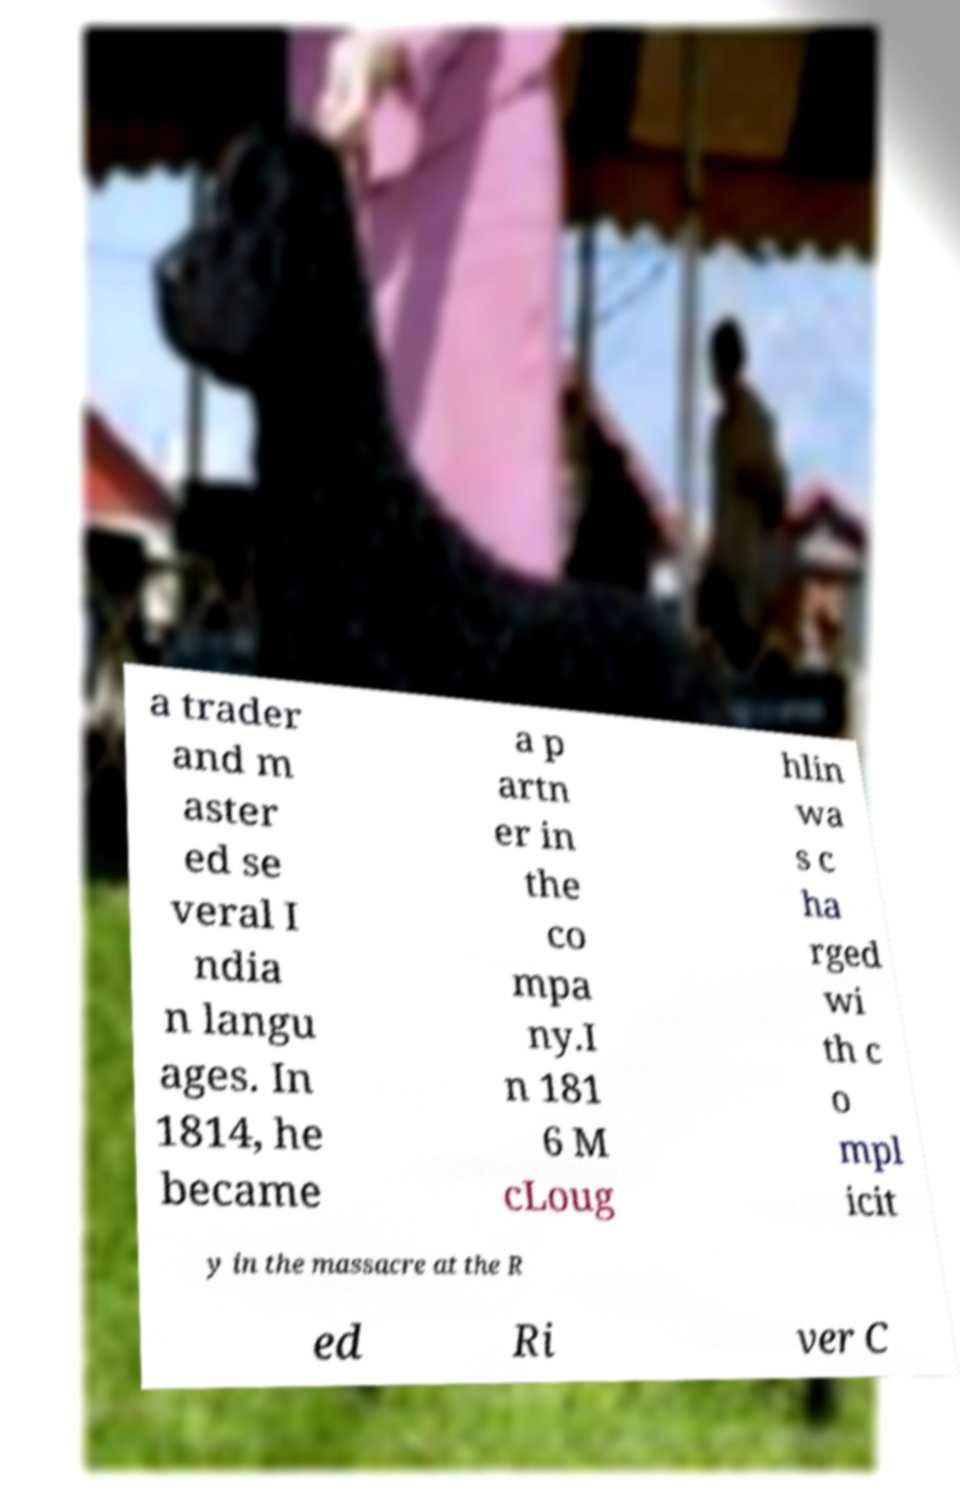Please read and relay the text visible in this image. What does it say? a trader and m aster ed se veral I ndia n langu ages. In 1814, he became a p artn er in the co mpa ny.I n 181 6 M cLoug hlin wa s c ha rged wi th c o mpl icit y in the massacre at the R ed Ri ver C 